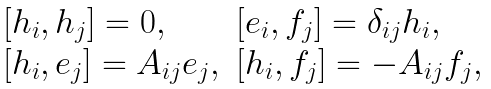Convert formula to latex. <formula><loc_0><loc_0><loc_500><loc_500>\begin{array} { l l } { { [ h _ { i } , h _ { j } ] = 0 , } } & { { [ e _ { i } , f _ { j } ] = \delta _ { i j } h _ { i } , } } \\ { { [ h _ { i } , e _ { j } ] = A _ { i j } e _ { j } , } } & { { [ h _ { i } , f _ { j } ] = - A _ { i j } f _ { j } , } } \end{array}</formula> 